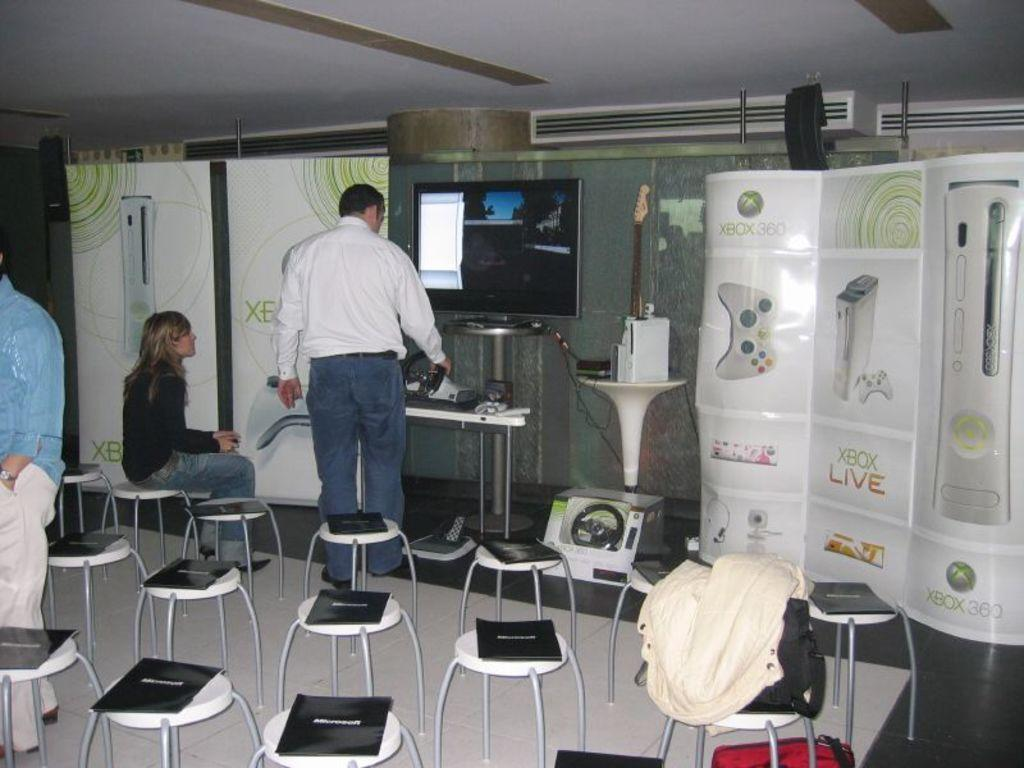<image>
Share a concise interpretation of the image provided. Booklets are sitting on stools outside an XBox Live display. 